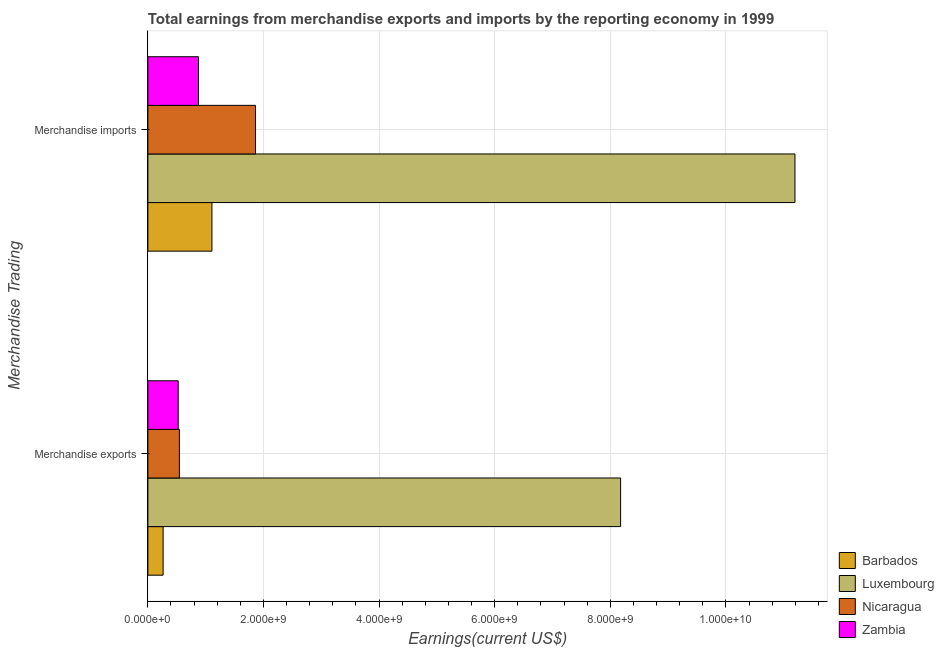How many groups of bars are there?
Make the answer very short. 2. Are the number of bars per tick equal to the number of legend labels?
Offer a very short reply. Yes. Are the number of bars on each tick of the Y-axis equal?
Offer a terse response. Yes. How many bars are there on the 2nd tick from the top?
Your answer should be compact. 4. What is the label of the 1st group of bars from the top?
Offer a very short reply. Merchandise imports. What is the earnings from merchandise exports in Nicaragua?
Provide a succinct answer. 5.45e+08. Across all countries, what is the maximum earnings from merchandise exports?
Keep it short and to the point. 8.18e+09. Across all countries, what is the minimum earnings from merchandise exports?
Offer a terse response. 2.64e+08. In which country was the earnings from merchandise imports maximum?
Give a very brief answer. Luxembourg. In which country was the earnings from merchandise exports minimum?
Your response must be concise. Barbados. What is the total earnings from merchandise exports in the graph?
Offer a very short reply. 9.51e+09. What is the difference between the earnings from merchandise imports in Zambia and that in Luxembourg?
Provide a short and direct response. -1.03e+1. What is the difference between the earnings from merchandise imports in Luxembourg and the earnings from merchandise exports in Nicaragua?
Make the answer very short. 1.06e+1. What is the average earnings from merchandise imports per country?
Ensure brevity in your answer.  3.76e+09. What is the difference between the earnings from merchandise imports and earnings from merchandise exports in Zambia?
Offer a very short reply. 3.51e+08. In how many countries, is the earnings from merchandise imports greater than 800000000 US$?
Offer a very short reply. 4. What is the ratio of the earnings from merchandise exports in Zambia to that in Nicaragua?
Your answer should be compact. 0.96. Is the earnings from merchandise exports in Luxembourg less than that in Nicaragua?
Your answer should be compact. No. What does the 1st bar from the top in Merchandise imports represents?
Keep it short and to the point. Zambia. What does the 3rd bar from the bottom in Merchandise exports represents?
Keep it short and to the point. Nicaragua. What is the difference between two consecutive major ticks on the X-axis?
Your response must be concise. 2.00e+09. Does the graph contain any zero values?
Give a very brief answer. No. Does the graph contain grids?
Provide a short and direct response. Yes. Where does the legend appear in the graph?
Offer a terse response. Bottom right. How many legend labels are there?
Your answer should be compact. 4. How are the legend labels stacked?
Ensure brevity in your answer.  Vertical. What is the title of the graph?
Make the answer very short. Total earnings from merchandise exports and imports by the reporting economy in 1999. What is the label or title of the X-axis?
Make the answer very short. Earnings(current US$). What is the label or title of the Y-axis?
Give a very brief answer. Merchandise Trading. What is the Earnings(current US$) of Barbados in Merchandise exports?
Make the answer very short. 2.64e+08. What is the Earnings(current US$) of Luxembourg in Merchandise exports?
Ensure brevity in your answer.  8.18e+09. What is the Earnings(current US$) of Nicaragua in Merchandise exports?
Your answer should be compact. 5.45e+08. What is the Earnings(current US$) of Zambia in Merchandise exports?
Keep it short and to the point. 5.25e+08. What is the Earnings(current US$) in Barbados in Merchandise imports?
Your response must be concise. 1.11e+09. What is the Earnings(current US$) of Luxembourg in Merchandise imports?
Give a very brief answer. 1.12e+1. What is the Earnings(current US$) of Nicaragua in Merchandise imports?
Your answer should be compact. 1.86e+09. What is the Earnings(current US$) in Zambia in Merchandise imports?
Keep it short and to the point. 8.76e+08. Across all Merchandise Trading, what is the maximum Earnings(current US$) of Barbados?
Your answer should be compact. 1.11e+09. Across all Merchandise Trading, what is the maximum Earnings(current US$) of Luxembourg?
Ensure brevity in your answer.  1.12e+1. Across all Merchandise Trading, what is the maximum Earnings(current US$) in Nicaragua?
Provide a short and direct response. 1.86e+09. Across all Merchandise Trading, what is the maximum Earnings(current US$) in Zambia?
Ensure brevity in your answer.  8.76e+08. Across all Merchandise Trading, what is the minimum Earnings(current US$) in Barbados?
Make the answer very short. 2.64e+08. Across all Merchandise Trading, what is the minimum Earnings(current US$) of Luxembourg?
Make the answer very short. 8.18e+09. Across all Merchandise Trading, what is the minimum Earnings(current US$) of Nicaragua?
Provide a short and direct response. 5.45e+08. Across all Merchandise Trading, what is the minimum Earnings(current US$) of Zambia?
Provide a succinct answer. 5.25e+08. What is the total Earnings(current US$) in Barbados in the graph?
Give a very brief answer. 1.37e+09. What is the total Earnings(current US$) in Luxembourg in the graph?
Your answer should be very brief. 1.94e+1. What is the total Earnings(current US$) in Nicaragua in the graph?
Your response must be concise. 2.41e+09. What is the total Earnings(current US$) in Zambia in the graph?
Provide a succinct answer. 1.40e+09. What is the difference between the Earnings(current US$) in Barbados in Merchandise exports and that in Merchandise imports?
Your answer should be very brief. -8.44e+08. What is the difference between the Earnings(current US$) of Luxembourg in Merchandise exports and that in Merchandise imports?
Ensure brevity in your answer.  -3.02e+09. What is the difference between the Earnings(current US$) in Nicaragua in Merchandise exports and that in Merchandise imports?
Your answer should be very brief. -1.32e+09. What is the difference between the Earnings(current US$) of Zambia in Merchandise exports and that in Merchandise imports?
Provide a short and direct response. -3.51e+08. What is the difference between the Earnings(current US$) in Barbados in Merchandise exports and the Earnings(current US$) in Luxembourg in Merchandise imports?
Provide a succinct answer. -1.09e+1. What is the difference between the Earnings(current US$) of Barbados in Merchandise exports and the Earnings(current US$) of Nicaragua in Merchandise imports?
Ensure brevity in your answer.  -1.60e+09. What is the difference between the Earnings(current US$) in Barbados in Merchandise exports and the Earnings(current US$) in Zambia in Merchandise imports?
Provide a short and direct response. -6.12e+08. What is the difference between the Earnings(current US$) of Luxembourg in Merchandise exports and the Earnings(current US$) of Nicaragua in Merchandise imports?
Your answer should be very brief. 6.32e+09. What is the difference between the Earnings(current US$) of Luxembourg in Merchandise exports and the Earnings(current US$) of Zambia in Merchandise imports?
Keep it short and to the point. 7.30e+09. What is the difference between the Earnings(current US$) in Nicaragua in Merchandise exports and the Earnings(current US$) in Zambia in Merchandise imports?
Your response must be concise. -3.31e+08. What is the average Earnings(current US$) in Barbados per Merchandise Trading?
Give a very brief answer. 6.86e+08. What is the average Earnings(current US$) of Luxembourg per Merchandise Trading?
Provide a succinct answer. 9.69e+09. What is the average Earnings(current US$) in Nicaragua per Merchandise Trading?
Your answer should be very brief. 1.20e+09. What is the average Earnings(current US$) in Zambia per Merchandise Trading?
Ensure brevity in your answer.  7.00e+08. What is the difference between the Earnings(current US$) in Barbados and Earnings(current US$) in Luxembourg in Merchandise exports?
Your response must be concise. -7.91e+09. What is the difference between the Earnings(current US$) of Barbados and Earnings(current US$) of Nicaragua in Merchandise exports?
Provide a short and direct response. -2.81e+08. What is the difference between the Earnings(current US$) in Barbados and Earnings(current US$) in Zambia in Merchandise exports?
Provide a short and direct response. -2.61e+08. What is the difference between the Earnings(current US$) in Luxembourg and Earnings(current US$) in Nicaragua in Merchandise exports?
Your answer should be very brief. 7.63e+09. What is the difference between the Earnings(current US$) of Luxembourg and Earnings(current US$) of Zambia in Merchandise exports?
Provide a succinct answer. 7.65e+09. What is the difference between the Earnings(current US$) of Nicaragua and Earnings(current US$) of Zambia in Merchandise exports?
Offer a very short reply. 2.04e+07. What is the difference between the Earnings(current US$) of Barbados and Earnings(current US$) of Luxembourg in Merchandise imports?
Provide a succinct answer. -1.01e+1. What is the difference between the Earnings(current US$) of Barbados and Earnings(current US$) of Nicaragua in Merchandise imports?
Keep it short and to the point. -7.54e+08. What is the difference between the Earnings(current US$) in Barbados and Earnings(current US$) in Zambia in Merchandise imports?
Offer a terse response. 2.32e+08. What is the difference between the Earnings(current US$) in Luxembourg and Earnings(current US$) in Nicaragua in Merchandise imports?
Your response must be concise. 9.33e+09. What is the difference between the Earnings(current US$) in Luxembourg and Earnings(current US$) in Zambia in Merchandise imports?
Make the answer very short. 1.03e+1. What is the difference between the Earnings(current US$) of Nicaragua and Earnings(current US$) of Zambia in Merchandise imports?
Keep it short and to the point. 9.86e+08. What is the ratio of the Earnings(current US$) in Barbados in Merchandise exports to that in Merchandise imports?
Give a very brief answer. 0.24. What is the ratio of the Earnings(current US$) in Luxembourg in Merchandise exports to that in Merchandise imports?
Your answer should be very brief. 0.73. What is the ratio of the Earnings(current US$) of Nicaragua in Merchandise exports to that in Merchandise imports?
Provide a succinct answer. 0.29. What is the ratio of the Earnings(current US$) of Zambia in Merchandise exports to that in Merchandise imports?
Provide a short and direct response. 0.6. What is the difference between the highest and the second highest Earnings(current US$) in Barbados?
Provide a succinct answer. 8.44e+08. What is the difference between the highest and the second highest Earnings(current US$) in Luxembourg?
Provide a short and direct response. 3.02e+09. What is the difference between the highest and the second highest Earnings(current US$) in Nicaragua?
Your answer should be compact. 1.32e+09. What is the difference between the highest and the second highest Earnings(current US$) in Zambia?
Your answer should be compact. 3.51e+08. What is the difference between the highest and the lowest Earnings(current US$) of Barbados?
Your response must be concise. 8.44e+08. What is the difference between the highest and the lowest Earnings(current US$) of Luxembourg?
Offer a terse response. 3.02e+09. What is the difference between the highest and the lowest Earnings(current US$) of Nicaragua?
Provide a short and direct response. 1.32e+09. What is the difference between the highest and the lowest Earnings(current US$) of Zambia?
Your answer should be very brief. 3.51e+08. 